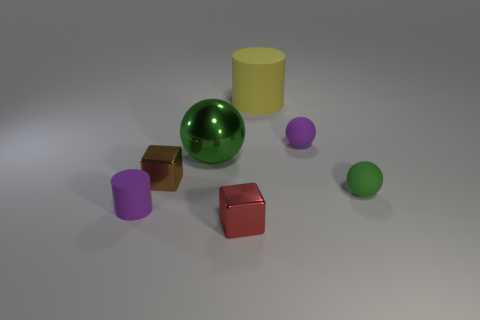There is a large object that is in front of the small rubber sphere left of the green rubber thing; what number of rubber objects are behind it?
Make the answer very short. 2. Are there any green spheres to the left of the small red block?
Provide a short and direct response. Yes. What number of other things are the same size as the brown object?
Provide a succinct answer. 4. What material is the object that is on the left side of the yellow rubber object and on the right side of the big shiny ball?
Your response must be concise. Metal. There is a green object that is to the left of the big rubber thing; is its shape the same as the green object on the right side of the yellow cylinder?
Make the answer very short. Yes. There is a large object that is behind the small purple matte object behind the tiny purple thing to the left of the large yellow cylinder; what is its shape?
Your answer should be compact. Cylinder. What number of other things are the same shape as the large rubber object?
Your response must be concise. 1. What color is the shiny cube that is the same size as the brown thing?
Give a very brief answer. Red. What number of spheres are either purple matte things or small red things?
Ensure brevity in your answer.  1. How many rubber things are there?
Ensure brevity in your answer.  4. 